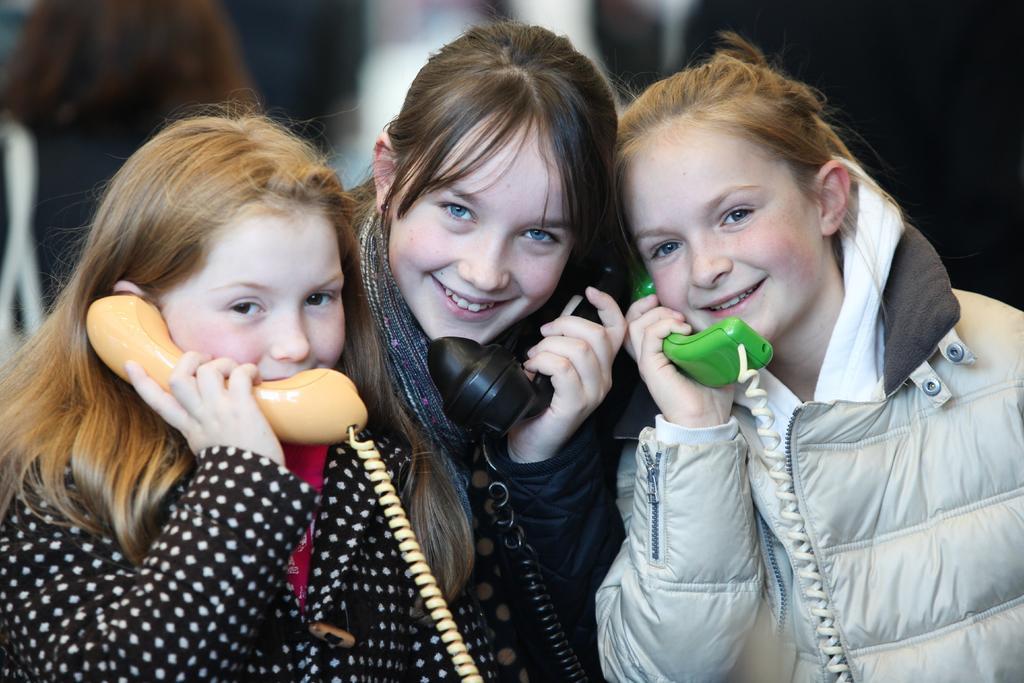Please provide a concise description of this image. In the image we can see there are three girls standing and they are holding telephones in their hand. They are wearing jackets. 